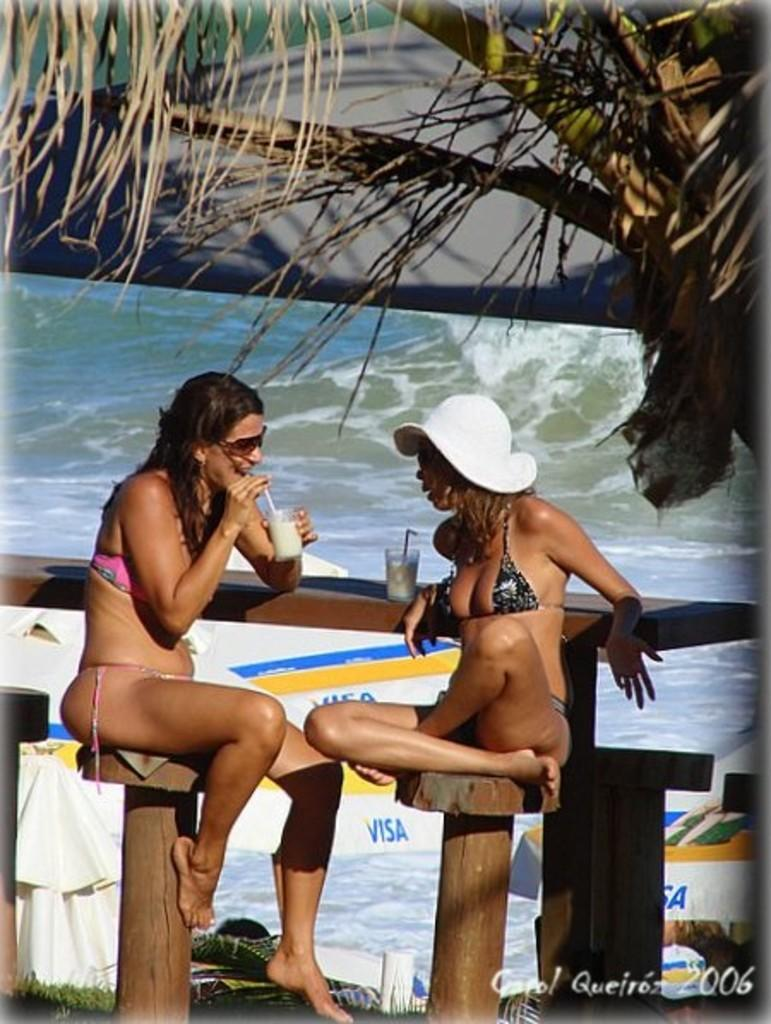How many people are present in the image? There are two people in the image. What objects can be seen in the image besides the people? There are glasses and a tree visible in the image. What natural element is present in the image? There is water visible in the image. What type of amusement can be seen in the image? There is no amusement present in the image; it features two people, glasses, a tree, and water. Can you tell me how many knives are visible in the image? There are no knives present in the image. 